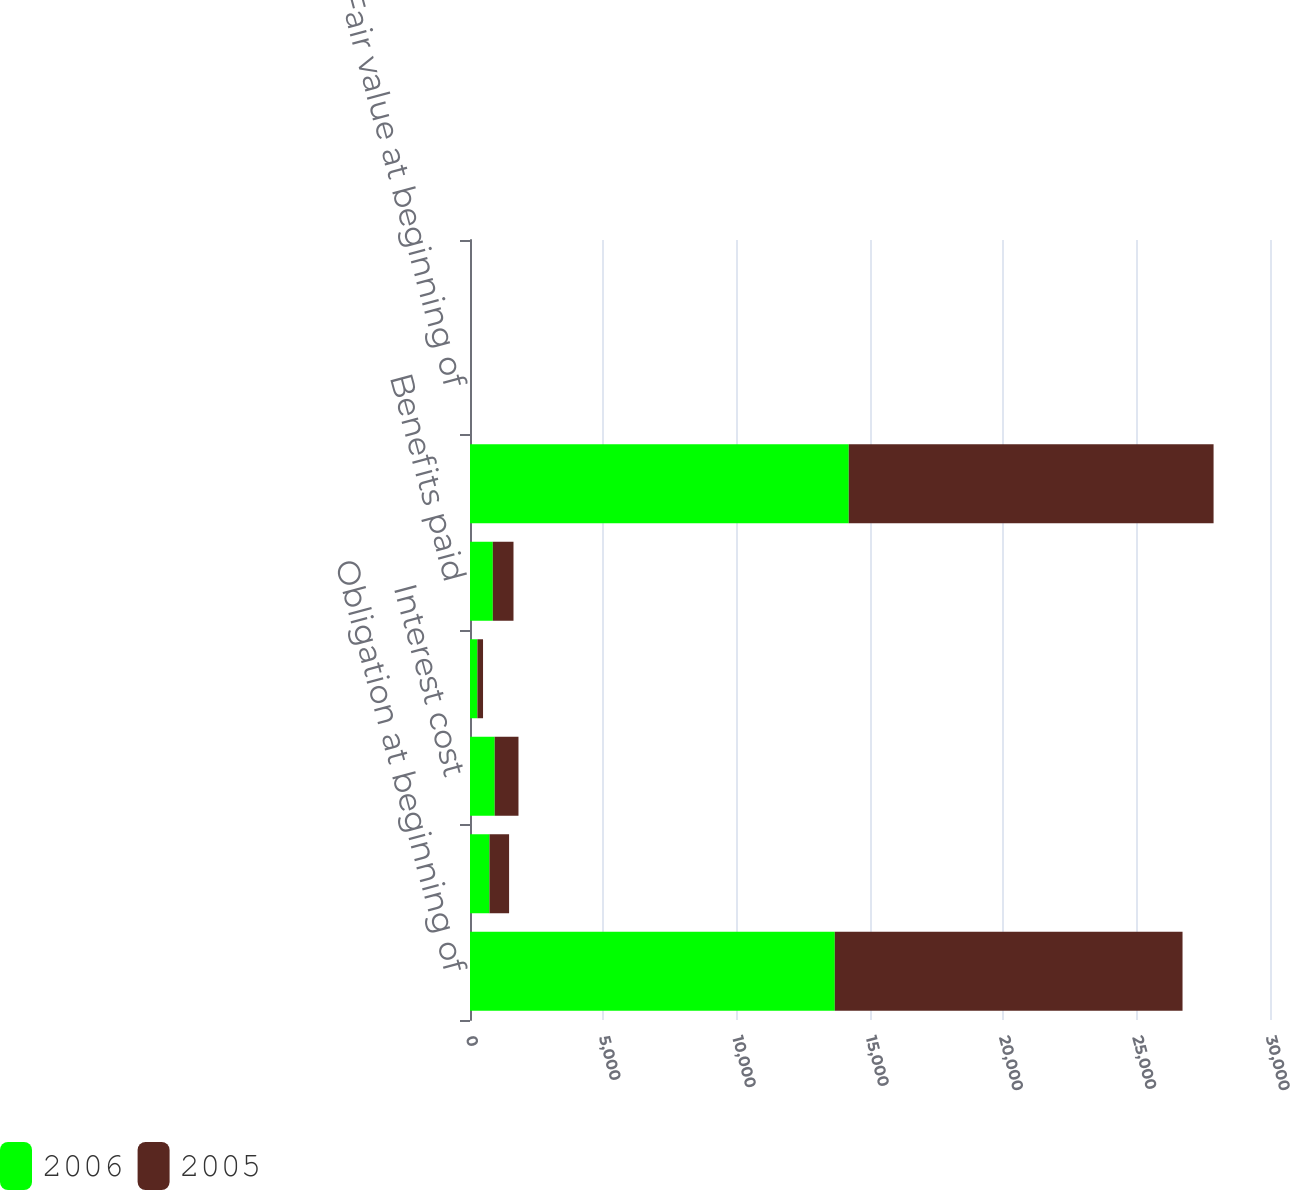Convert chart. <chart><loc_0><loc_0><loc_500><loc_500><stacked_bar_chart><ecel><fcel>Obligation at beginning of<fcel>Service cost<fcel>Interest cost<fcel>Actuarial loss (gain)<fcel>Benefits paid<fcel>Obligation at end of year<fcel>Fair value at beginning of<fcel>Return on assets<nl><fcel>2006<fcel>13680<fcel>731<fcel>927<fcel>278<fcel>856<fcel>14204<fcel>0<fcel>0<nl><fcel>2005<fcel>13040<fcel>735<fcel>891<fcel>211<fcel>775<fcel>13680<fcel>0<fcel>0<nl></chart> 